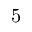Convert formula to latex. <formula><loc_0><loc_0><loc_500><loc_500>5</formula> 